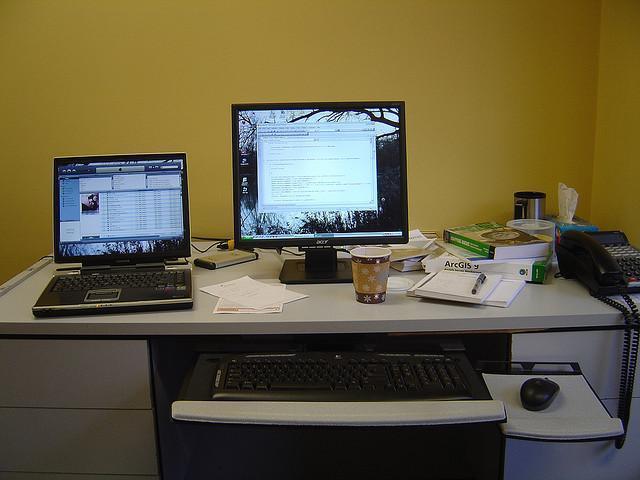How many books are in the photo?
Give a very brief answer. 2. 